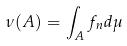<formula> <loc_0><loc_0><loc_500><loc_500>\nu ( A ) = \int _ { A } f _ { n } d \mu</formula> 